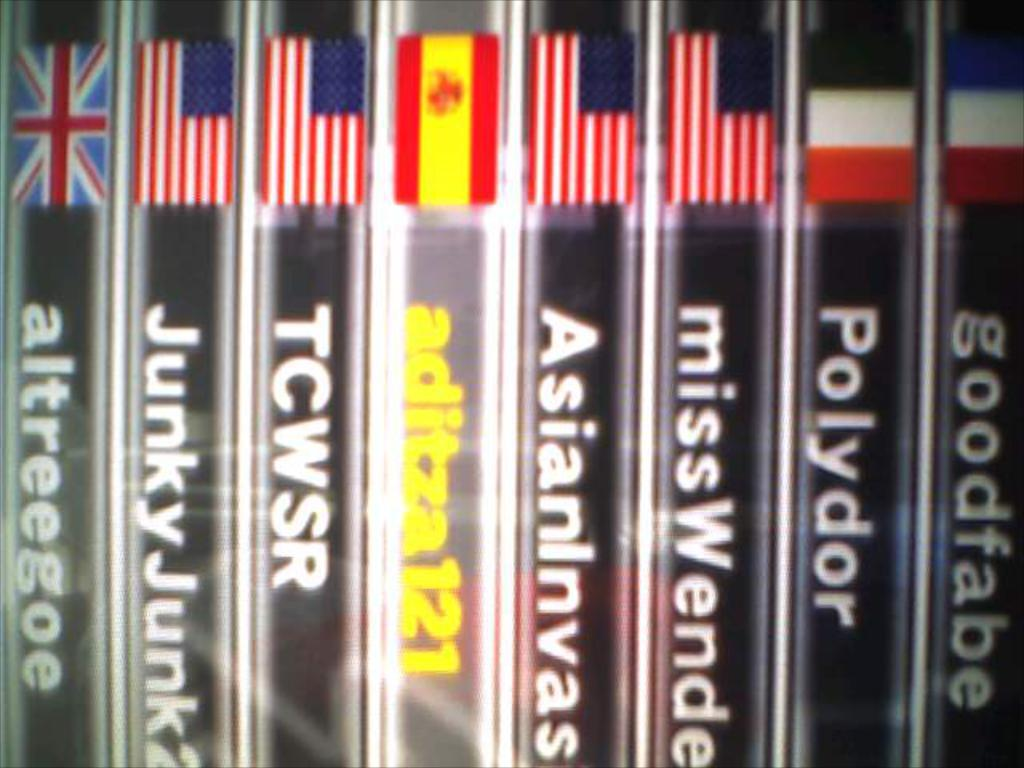<image>
Summarize the visual content of the image. Book for "missWende" between some other books with flags on it. 